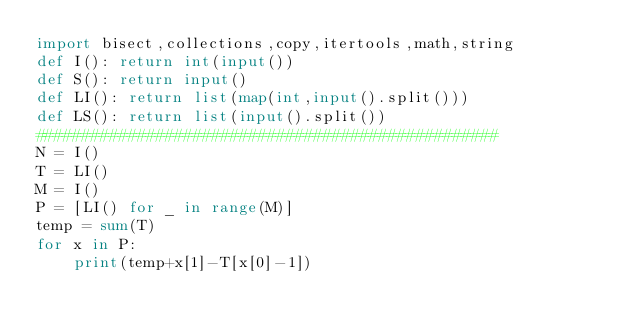Convert code to text. <code><loc_0><loc_0><loc_500><loc_500><_Python_>import bisect,collections,copy,itertools,math,string
def I(): return int(input())
def S(): return input()
def LI(): return list(map(int,input().split()))
def LS(): return list(input().split())
##################################################
N = I()
T = LI()
M = I()
P = [LI() for _ in range(M)]
temp = sum(T)
for x in P:
    print(temp+x[1]-T[x[0]-1])</code> 